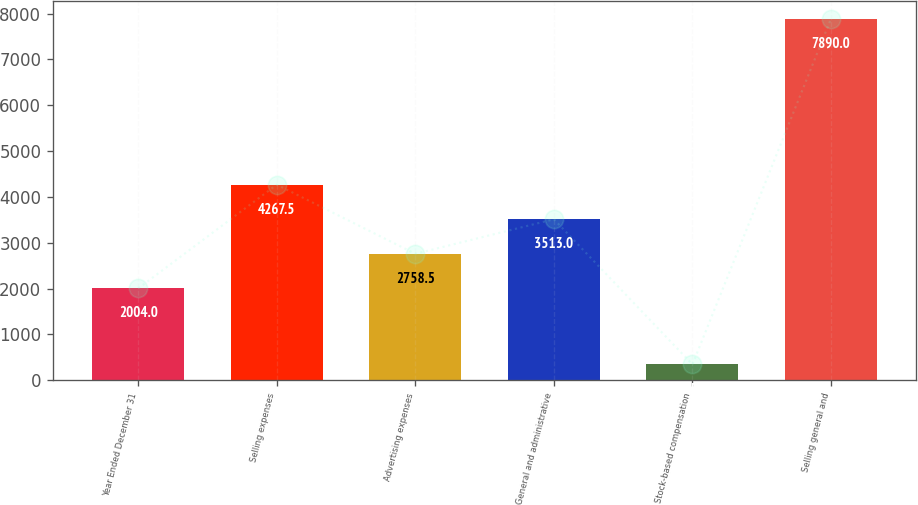Convert chart to OTSL. <chart><loc_0><loc_0><loc_500><loc_500><bar_chart><fcel>Year Ended December 31<fcel>Selling expenses<fcel>Advertising expenses<fcel>General and administrative<fcel>Stock-based compensation<fcel>Selling general and<nl><fcel>2004<fcel>4267.5<fcel>2758.5<fcel>3513<fcel>345<fcel>7890<nl></chart> 